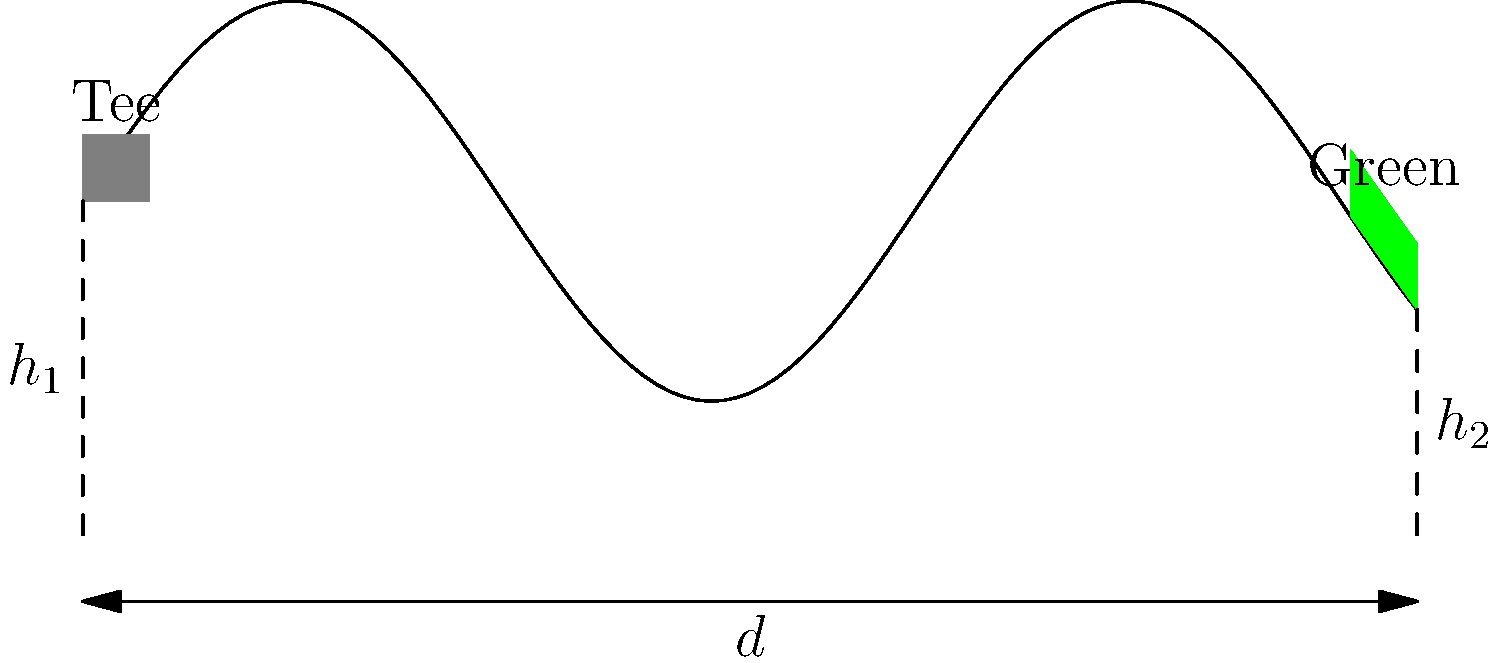In designing a par-3 hole with elevation changes, you want to create a challenging yet fair experience. Given the side-view profile above, where $h_1$ represents the height of the tee box, $h_2$ the height of the green, and $d$ the horizontal distance between them, how would you calculate the effective playing distance of the hole? Assume the ball flight is not affected by wind or other external factors. To calculate the effective playing distance of the hole, we need to consider both the horizontal distance and the elevation change. Here's a step-by-step approach:

1. Identify the known variables:
   - $h_1$: Height of the tee box
   - $h_2$: Height of the green
   - $d$: Horizontal distance between tee and green

2. Calculate the vertical elevation change:
   $\Delta h = h_2 - h_1$

3. Use the Pythagorean theorem to find the effective playing distance:
   Let $x$ be the effective playing distance.
   $x^2 = d^2 + (\Delta h)^2$

4. Solve for $x$:
   $x = \sqrt{d^2 + (\Delta h)^2}$

5. This formula gives us the straight-line distance from the tee to the green, accounting for both horizontal distance and elevation change.

6. In golf course design, it's common to use a rule of thumb that for every 1 yard of elevation change, add or subtract 1 yard to the playing distance:
   Adjusted distance = $d + \Delta h$ (if the green is higher)
   Adjusted distance = $d - \Delta h$ (if the green is lower)

7. Compare both methods and use professional judgment to determine which better represents the actual playing experience for golfers.
Answer: Effective playing distance = $\sqrt{d^2 + (\Delta h)^2}$ or $d \pm \Delta h$ 